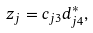Convert formula to latex. <formula><loc_0><loc_0><loc_500><loc_500>z _ { j } = c _ { j 3 } d ^ { \ast } _ { j 4 } ,</formula> 